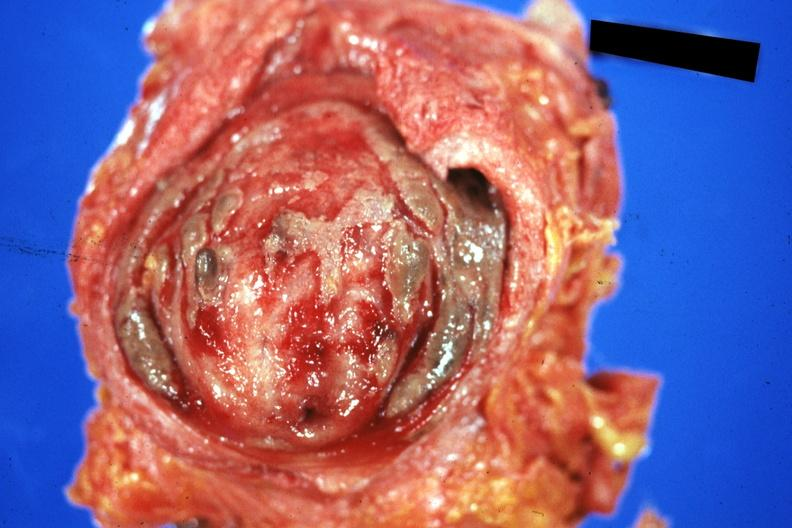s urinary present?
Answer the question using a single word or phrase. Yes 